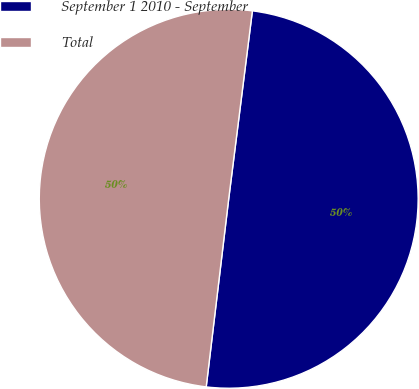<chart> <loc_0><loc_0><loc_500><loc_500><pie_chart><fcel>September 1 2010 - September<fcel>Total<nl><fcel>49.9%<fcel>50.1%<nl></chart> 